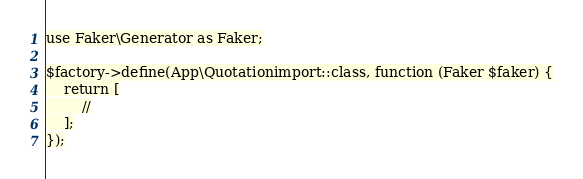Convert code to text. <code><loc_0><loc_0><loc_500><loc_500><_PHP_>
use Faker\Generator as Faker;

$factory->define(App\Quotationimport::class, function (Faker $faker) {
    return [
        //
    ];
});
</code> 